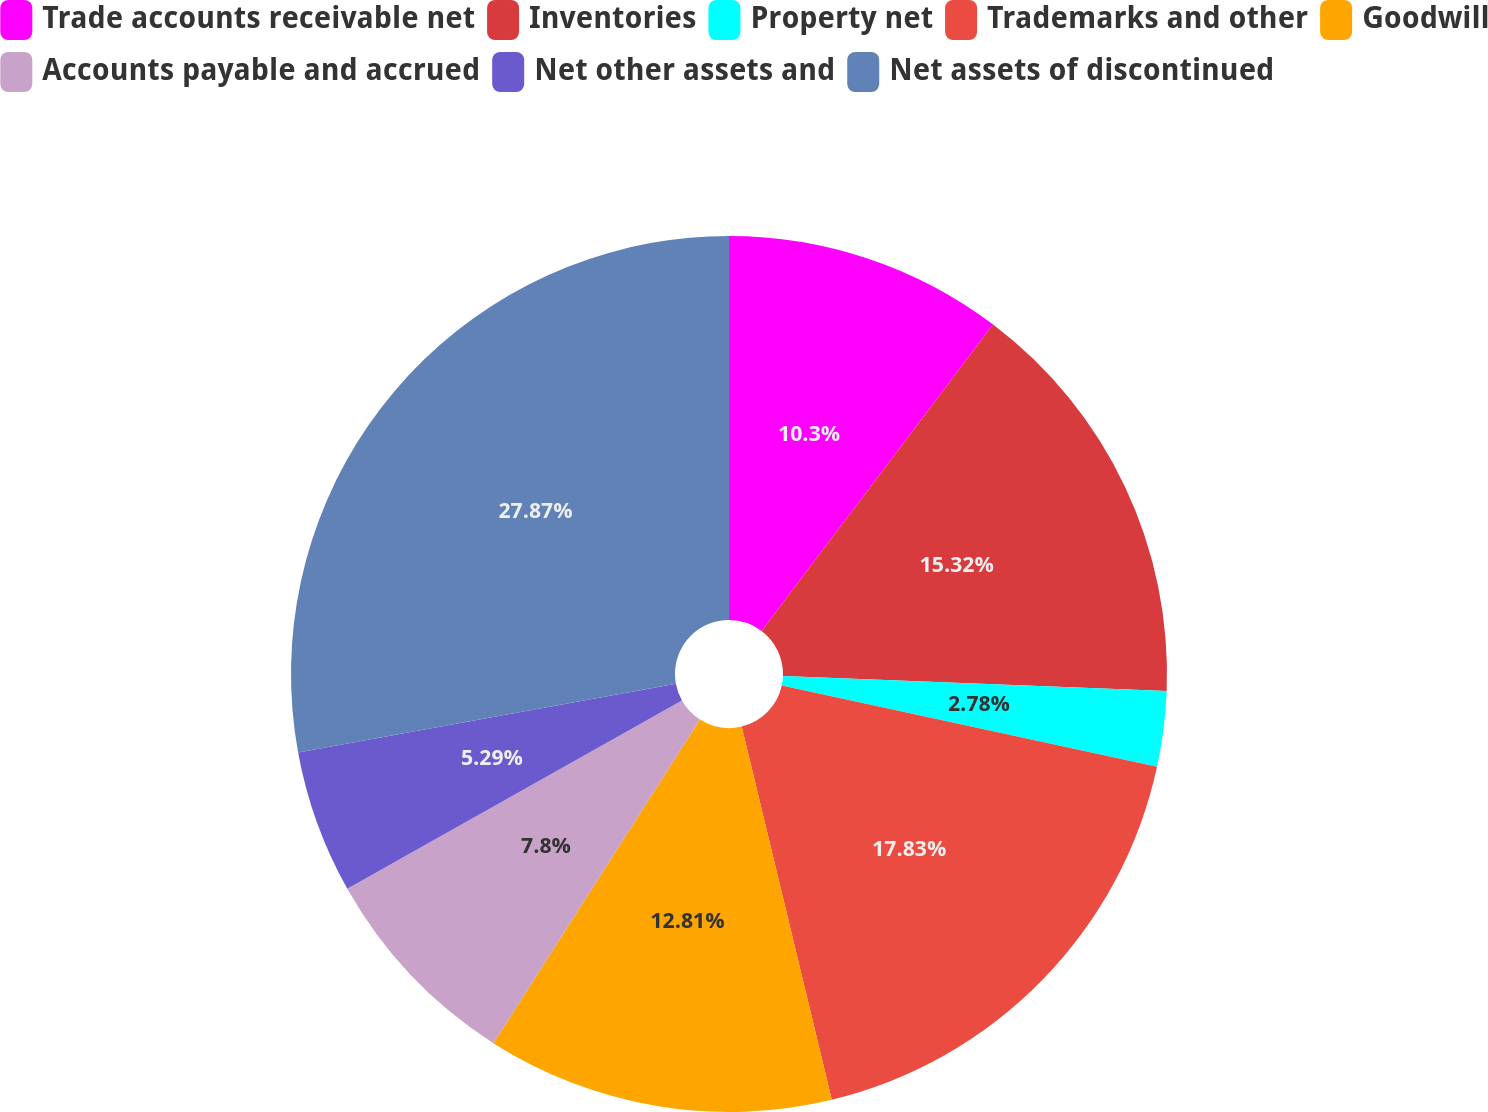Convert chart. <chart><loc_0><loc_0><loc_500><loc_500><pie_chart><fcel>Trade accounts receivable net<fcel>Inventories<fcel>Property net<fcel>Trademarks and other<fcel>Goodwill<fcel>Accounts payable and accrued<fcel>Net other assets and<fcel>Net assets of discontinued<nl><fcel>10.3%<fcel>15.32%<fcel>2.78%<fcel>17.83%<fcel>12.81%<fcel>7.8%<fcel>5.29%<fcel>27.87%<nl></chart> 